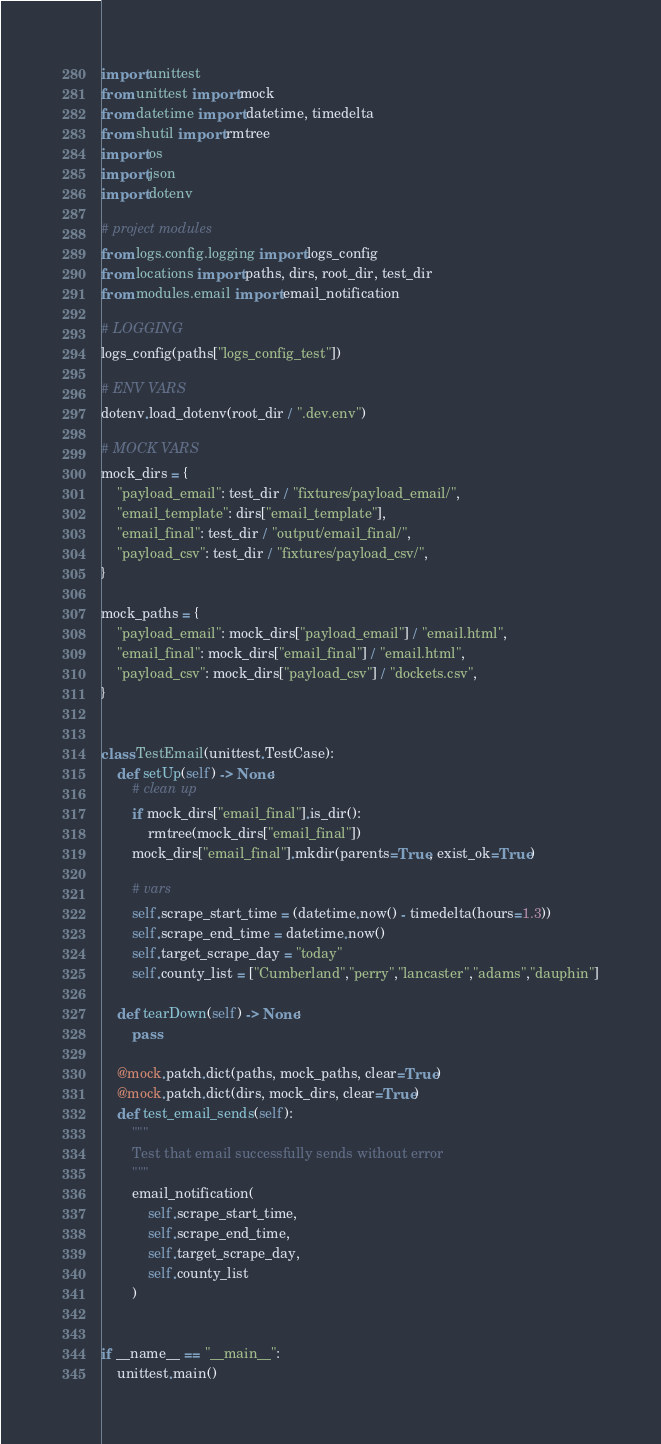Convert code to text. <code><loc_0><loc_0><loc_500><loc_500><_Python_>import unittest
from unittest import mock
from datetime import datetime, timedelta
from shutil import rmtree
import os
import json
import dotenv

# project modules
from logs.config.logging import logs_config
from locations import paths, dirs, root_dir, test_dir
from modules.email import email_notification

# LOGGING
logs_config(paths["logs_config_test"])

# ENV VARS
dotenv.load_dotenv(root_dir / ".dev.env")

# MOCK VARS
mock_dirs = {
    "payload_email": test_dir / "fixtures/payload_email/",
    "email_template": dirs["email_template"],
    "email_final": test_dir / "output/email_final/",
    "payload_csv": test_dir / "fixtures/payload_csv/",
}

mock_paths = {
    "payload_email": mock_dirs["payload_email"] / "email.html",
    "email_final": mock_dirs["email_final"] / "email.html",
    "payload_csv": mock_dirs["payload_csv"] / "dockets.csv",
}


class TestEmail(unittest.TestCase):
    def setUp(self) -> None:
        # clean up
        if mock_dirs["email_final"].is_dir():
            rmtree(mock_dirs["email_final"])
        mock_dirs["email_final"].mkdir(parents=True, exist_ok=True)

        # vars
        self.scrape_start_time = (datetime.now() - timedelta(hours=1.3))
        self.scrape_end_time = datetime.now()
        self.target_scrape_day = "today"
        self.county_list = ["Cumberland","perry","lancaster","adams","dauphin"]

    def tearDown(self) -> None:
        pass

    @mock.patch.dict(paths, mock_paths, clear=True)
    @mock.patch.dict(dirs, mock_dirs, clear=True)
    def test_email_sends(self):
        """
        Test that email successfully sends without error
        """
        email_notification(
            self.scrape_start_time,
            self.scrape_end_time,
            self.target_scrape_day,
            self.county_list
        )


if __name__ == "__main__":
    unittest.main()
</code> 